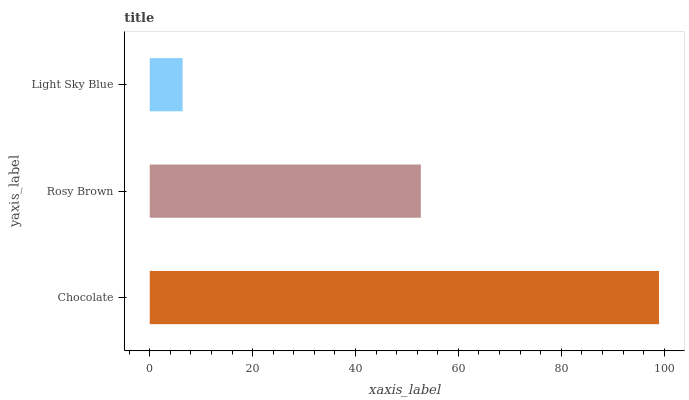Is Light Sky Blue the minimum?
Answer yes or no. Yes. Is Chocolate the maximum?
Answer yes or no. Yes. Is Rosy Brown the minimum?
Answer yes or no. No. Is Rosy Brown the maximum?
Answer yes or no. No. Is Chocolate greater than Rosy Brown?
Answer yes or no. Yes. Is Rosy Brown less than Chocolate?
Answer yes or no. Yes. Is Rosy Brown greater than Chocolate?
Answer yes or no. No. Is Chocolate less than Rosy Brown?
Answer yes or no. No. Is Rosy Brown the high median?
Answer yes or no. Yes. Is Rosy Brown the low median?
Answer yes or no. Yes. Is Light Sky Blue the high median?
Answer yes or no. No. Is Light Sky Blue the low median?
Answer yes or no. No. 